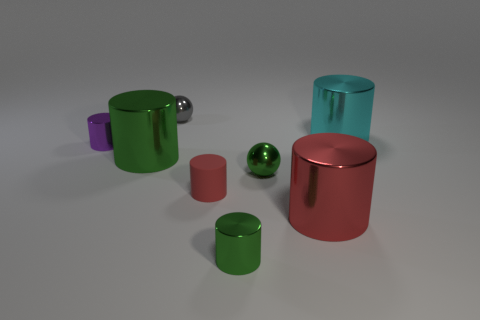How many green cylinders must be subtracted to get 1 green cylinders? 1 Subtract all matte cylinders. How many cylinders are left? 5 Add 1 red rubber cylinders. How many objects exist? 9 Subtract all gray balls. How many balls are left? 1 Subtract all cylinders. How many objects are left? 2 Subtract 1 spheres. How many spheres are left? 1 Subtract all cyan blocks. How many yellow cylinders are left? 0 Add 1 large green shiny cylinders. How many large green shiny cylinders exist? 2 Subtract 2 red cylinders. How many objects are left? 6 Subtract all green cylinders. Subtract all cyan blocks. How many cylinders are left? 4 